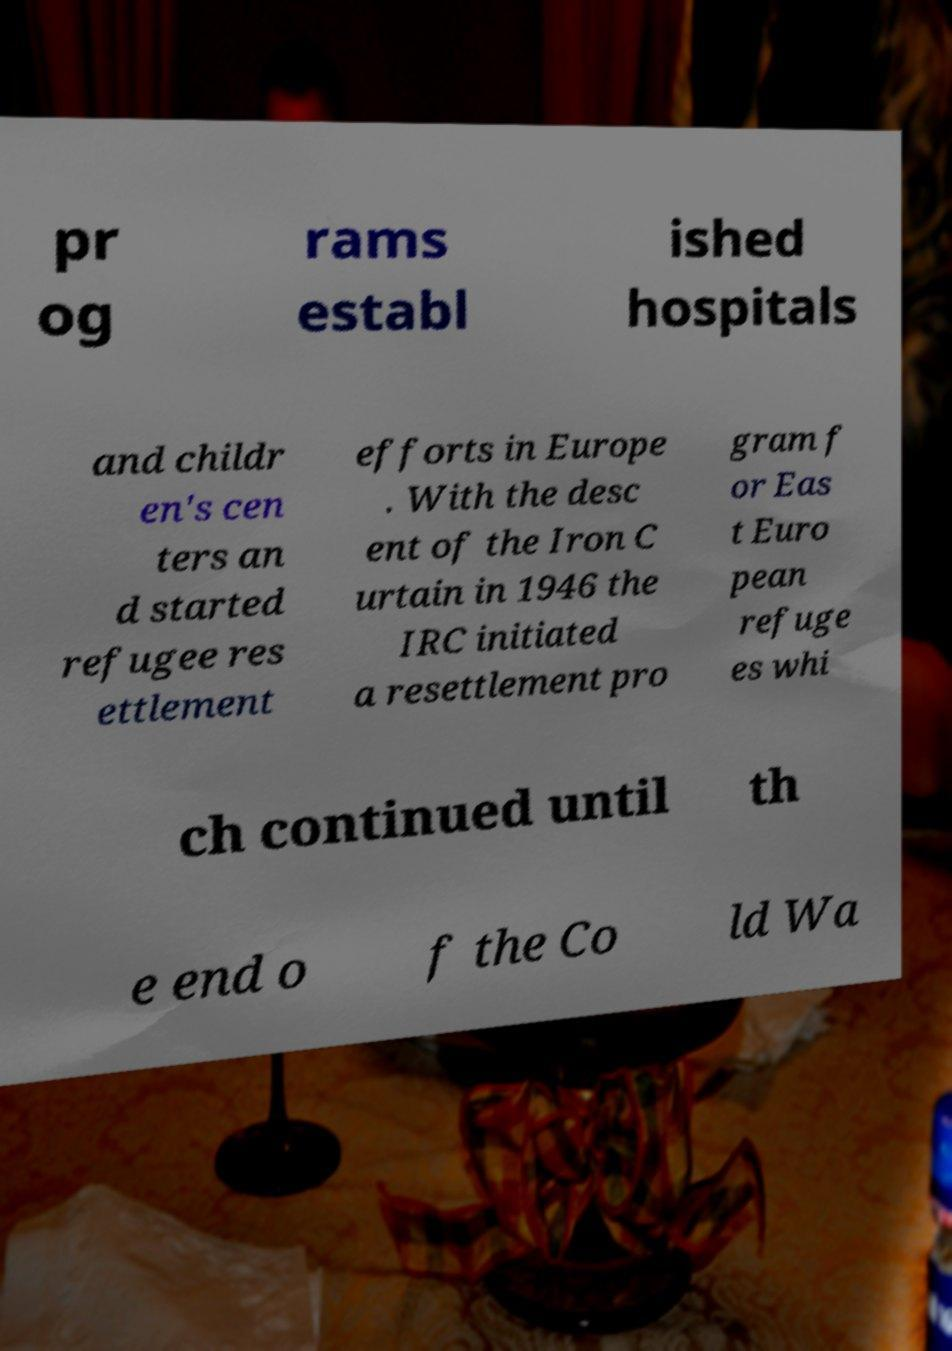Can you accurately transcribe the text from the provided image for me? pr og rams establ ished hospitals and childr en's cen ters an d started refugee res ettlement efforts in Europe . With the desc ent of the Iron C urtain in 1946 the IRC initiated a resettlement pro gram f or Eas t Euro pean refuge es whi ch continued until th e end o f the Co ld Wa 